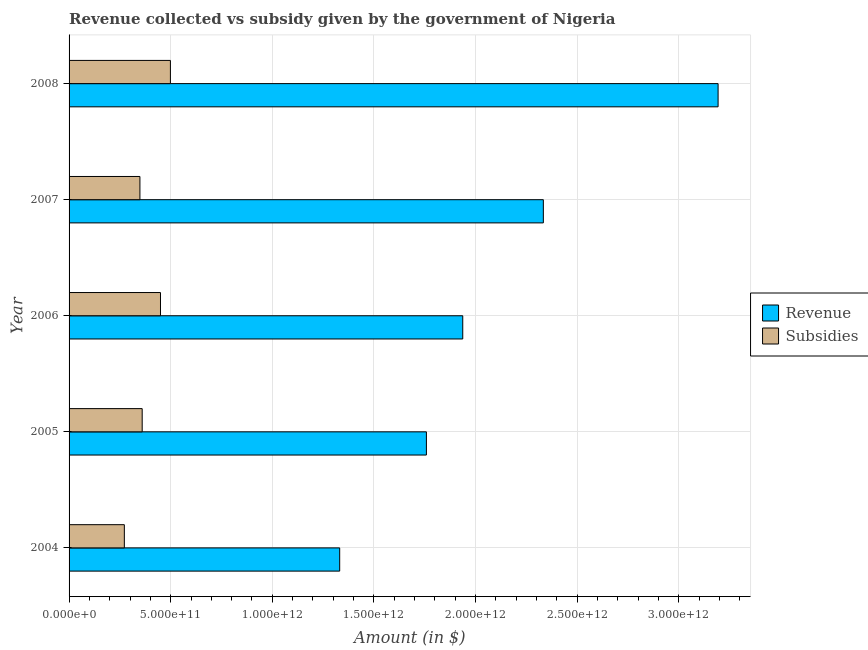How many different coloured bars are there?
Provide a succinct answer. 2. How many bars are there on the 3rd tick from the top?
Your response must be concise. 2. In how many cases, is the number of bars for a given year not equal to the number of legend labels?
Make the answer very short. 0. What is the amount of subsidies given in 2006?
Give a very brief answer. 4.50e+11. Across all years, what is the maximum amount of revenue collected?
Your response must be concise. 3.19e+12. Across all years, what is the minimum amount of subsidies given?
Your answer should be compact. 2.72e+11. What is the total amount of revenue collected in the graph?
Your response must be concise. 1.06e+13. What is the difference between the amount of revenue collected in 2005 and that in 2006?
Provide a succinct answer. -1.79e+11. What is the difference between the amount of subsidies given in 2008 and the amount of revenue collected in 2007?
Offer a terse response. -1.84e+12. What is the average amount of revenue collected per year?
Your answer should be compact. 2.11e+12. In the year 2007, what is the difference between the amount of revenue collected and amount of subsidies given?
Your answer should be compact. 1.99e+12. In how many years, is the amount of subsidies given greater than 1100000000000 $?
Offer a very short reply. 0. What is the ratio of the amount of revenue collected in 2005 to that in 2008?
Offer a terse response. 0.55. What is the difference between the highest and the second highest amount of revenue collected?
Your answer should be very brief. 8.60e+11. What is the difference between the highest and the lowest amount of revenue collected?
Give a very brief answer. 1.86e+12. In how many years, is the amount of revenue collected greater than the average amount of revenue collected taken over all years?
Provide a short and direct response. 2. Is the sum of the amount of revenue collected in 2004 and 2006 greater than the maximum amount of subsidies given across all years?
Your answer should be very brief. Yes. What does the 2nd bar from the top in 2005 represents?
Keep it short and to the point. Revenue. What does the 1st bar from the bottom in 2006 represents?
Provide a succinct answer. Revenue. How many bars are there?
Your response must be concise. 10. Are all the bars in the graph horizontal?
Ensure brevity in your answer.  Yes. What is the difference between two consecutive major ticks on the X-axis?
Provide a succinct answer. 5.00e+11. Does the graph contain any zero values?
Your answer should be compact. No. Does the graph contain grids?
Give a very brief answer. Yes. What is the title of the graph?
Your answer should be very brief. Revenue collected vs subsidy given by the government of Nigeria. Does "Male entrants" appear as one of the legend labels in the graph?
Offer a very short reply. No. What is the label or title of the X-axis?
Offer a terse response. Amount (in $). What is the label or title of the Y-axis?
Ensure brevity in your answer.  Year. What is the Amount (in $) in Revenue in 2004?
Ensure brevity in your answer.  1.33e+12. What is the Amount (in $) in Subsidies in 2004?
Ensure brevity in your answer.  2.72e+11. What is the Amount (in $) in Revenue in 2005?
Offer a terse response. 1.76e+12. What is the Amount (in $) in Subsidies in 2005?
Your answer should be compact. 3.60e+11. What is the Amount (in $) of Revenue in 2006?
Offer a terse response. 1.94e+12. What is the Amount (in $) of Subsidies in 2006?
Offer a terse response. 4.50e+11. What is the Amount (in $) in Revenue in 2007?
Keep it short and to the point. 2.33e+12. What is the Amount (in $) in Subsidies in 2007?
Keep it short and to the point. 3.49e+11. What is the Amount (in $) in Revenue in 2008?
Give a very brief answer. 3.19e+12. What is the Amount (in $) of Subsidies in 2008?
Your answer should be very brief. 4.99e+11. Across all years, what is the maximum Amount (in $) of Revenue?
Offer a very short reply. 3.19e+12. Across all years, what is the maximum Amount (in $) of Subsidies?
Your answer should be compact. 4.99e+11. Across all years, what is the minimum Amount (in $) in Revenue?
Offer a very short reply. 1.33e+12. Across all years, what is the minimum Amount (in $) of Subsidies?
Make the answer very short. 2.72e+11. What is the total Amount (in $) in Revenue in the graph?
Ensure brevity in your answer.  1.06e+13. What is the total Amount (in $) in Subsidies in the graph?
Give a very brief answer. 1.93e+12. What is the difference between the Amount (in $) in Revenue in 2004 and that in 2005?
Your answer should be very brief. -4.27e+11. What is the difference between the Amount (in $) in Subsidies in 2004 and that in 2005?
Your answer should be compact. -8.78e+1. What is the difference between the Amount (in $) in Revenue in 2004 and that in 2006?
Give a very brief answer. -6.06e+11. What is the difference between the Amount (in $) in Subsidies in 2004 and that in 2006?
Make the answer very short. -1.78e+11. What is the difference between the Amount (in $) of Revenue in 2004 and that in 2007?
Keep it short and to the point. -1.00e+12. What is the difference between the Amount (in $) of Subsidies in 2004 and that in 2007?
Keep it short and to the point. -7.66e+1. What is the difference between the Amount (in $) of Revenue in 2004 and that in 2008?
Make the answer very short. -1.86e+12. What is the difference between the Amount (in $) in Subsidies in 2004 and that in 2008?
Offer a terse response. -2.27e+11. What is the difference between the Amount (in $) in Revenue in 2005 and that in 2006?
Provide a short and direct response. -1.79e+11. What is the difference between the Amount (in $) in Subsidies in 2005 and that in 2006?
Your answer should be compact. -9.00e+1. What is the difference between the Amount (in $) in Revenue in 2005 and that in 2007?
Make the answer very short. -5.75e+11. What is the difference between the Amount (in $) of Subsidies in 2005 and that in 2007?
Offer a terse response. 1.12e+1. What is the difference between the Amount (in $) of Revenue in 2005 and that in 2008?
Offer a terse response. -1.44e+12. What is the difference between the Amount (in $) of Subsidies in 2005 and that in 2008?
Provide a succinct answer. -1.39e+11. What is the difference between the Amount (in $) of Revenue in 2006 and that in 2007?
Provide a succinct answer. -3.97e+11. What is the difference between the Amount (in $) of Subsidies in 2006 and that in 2007?
Your response must be concise. 1.01e+11. What is the difference between the Amount (in $) of Revenue in 2006 and that in 2008?
Keep it short and to the point. -1.26e+12. What is the difference between the Amount (in $) of Subsidies in 2006 and that in 2008?
Your answer should be compact. -4.88e+1. What is the difference between the Amount (in $) of Revenue in 2007 and that in 2008?
Your response must be concise. -8.60e+11. What is the difference between the Amount (in $) of Subsidies in 2007 and that in 2008?
Your answer should be compact. -1.50e+11. What is the difference between the Amount (in $) in Revenue in 2004 and the Amount (in $) in Subsidies in 2005?
Your answer should be compact. 9.72e+11. What is the difference between the Amount (in $) in Revenue in 2004 and the Amount (in $) in Subsidies in 2006?
Ensure brevity in your answer.  8.82e+11. What is the difference between the Amount (in $) of Revenue in 2004 and the Amount (in $) of Subsidies in 2007?
Your response must be concise. 9.83e+11. What is the difference between the Amount (in $) in Revenue in 2004 and the Amount (in $) in Subsidies in 2008?
Provide a succinct answer. 8.33e+11. What is the difference between the Amount (in $) in Revenue in 2005 and the Amount (in $) in Subsidies in 2006?
Your answer should be compact. 1.31e+12. What is the difference between the Amount (in $) of Revenue in 2005 and the Amount (in $) of Subsidies in 2007?
Give a very brief answer. 1.41e+12. What is the difference between the Amount (in $) of Revenue in 2005 and the Amount (in $) of Subsidies in 2008?
Your answer should be very brief. 1.26e+12. What is the difference between the Amount (in $) of Revenue in 2006 and the Amount (in $) of Subsidies in 2007?
Make the answer very short. 1.59e+12. What is the difference between the Amount (in $) in Revenue in 2006 and the Amount (in $) in Subsidies in 2008?
Offer a terse response. 1.44e+12. What is the difference between the Amount (in $) in Revenue in 2007 and the Amount (in $) in Subsidies in 2008?
Your answer should be compact. 1.84e+12. What is the average Amount (in $) in Revenue per year?
Offer a very short reply. 2.11e+12. What is the average Amount (in $) of Subsidies per year?
Provide a succinct answer. 3.86e+11. In the year 2004, what is the difference between the Amount (in $) in Revenue and Amount (in $) in Subsidies?
Offer a very short reply. 1.06e+12. In the year 2005, what is the difference between the Amount (in $) in Revenue and Amount (in $) in Subsidies?
Provide a succinct answer. 1.40e+12. In the year 2006, what is the difference between the Amount (in $) of Revenue and Amount (in $) of Subsidies?
Offer a terse response. 1.49e+12. In the year 2007, what is the difference between the Amount (in $) of Revenue and Amount (in $) of Subsidies?
Keep it short and to the point. 1.99e+12. In the year 2008, what is the difference between the Amount (in $) of Revenue and Amount (in $) of Subsidies?
Your answer should be compact. 2.69e+12. What is the ratio of the Amount (in $) in Revenue in 2004 to that in 2005?
Provide a succinct answer. 0.76. What is the ratio of the Amount (in $) in Subsidies in 2004 to that in 2005?
Ensure brevity in your answer.  0.76. What is the ratio of the Amount (in $) in Revenue in 2004 to that in 2006?
Give a very brief answer. 0.69. What is the ratio of the Amount (in $) in Subsidies in 2004 to that in 2006?
Your answer should be compact. 0.6. What is the ratio of the Amount (in $) of Revenue in 2004 to that in 2007?
Your answer should be compact. 0.57. What is the ratio of the Amount (in $) of Subsidies in 2004 to that in 2007?
Offer a terse response. 0.78. What is the ratio of the Amount (in $) of Revenue in 2004 to that in 2008?
Make the answer very short. 0.42. What is the ratio of the Amount (in $) of Subsidies in 2004 to that in 2008?
Provide a succinct answer. 0.55. What is the ratio of the Amount (in $) in Revenue in 2005 to that in 2006?
Offer a terse response. 0.91. What is the ratio of the Amount (in $) of Subsidies in 2005 to that in 2006?
Make the answer very short. 0.8. What is the ratio of the Amount (in $) of Revenue in 2005 to that in 2007?
Your answer should be compact. 0.75. What is the ratio of the Amount (in $) in Subsidies in 2005 to that in 2007?
Offer a very short reply. 1.03. What is the ratio of the Amount (in $) of Revenue in 2005 to that in 2008?
Your answer should be very brief. 0.55. What is the ratio of the Amount (in $) in Subsidies in 2005 to that in 2008?
Provide a succinct answer. 0.72. What is the ratio of the Amount (in $) in Revenue in 2006 to that in 2007?
Make the answer very short. 0.83. What is the ratio of the Amount (in $) in Subsidies in 2006 to that in 2007?
Make the answer very short. 1.29. What is the ratio of the Amount (in $) of Revenue in 2006 to that in 2008?
Your answer should be very brief. 0.61. What is the ratio of the Amount (in $) in Subsidies in 2006 to that in 2008?
Your response must be concise. 0.9. What is the ratio of the Amount (in $) of Revenue in 2007 to that in 2008?
Make the answer very short. 0.73. What is the ratio of the Amount (in $) in Subsidies in 2007 to that in 2008?
Offer a terse response. 0.7. What is the difference between the highest and the second highest Amount (in $) in Revenue?
Offer a very short reply. 8.60e+11. What is the difference between the highest and the second highest Amount (in $) in Subsidies?
Provide a succinct answer. 4.88e+1. What is the difference between the highest and the lowest Amount (in $) in Revenue?
Give a very brief answer. 1.86e+12. What is the difference between the highest and the lowest Amount (in $) in Subsidies?
Offer a very short reply. 2.27e+11. 